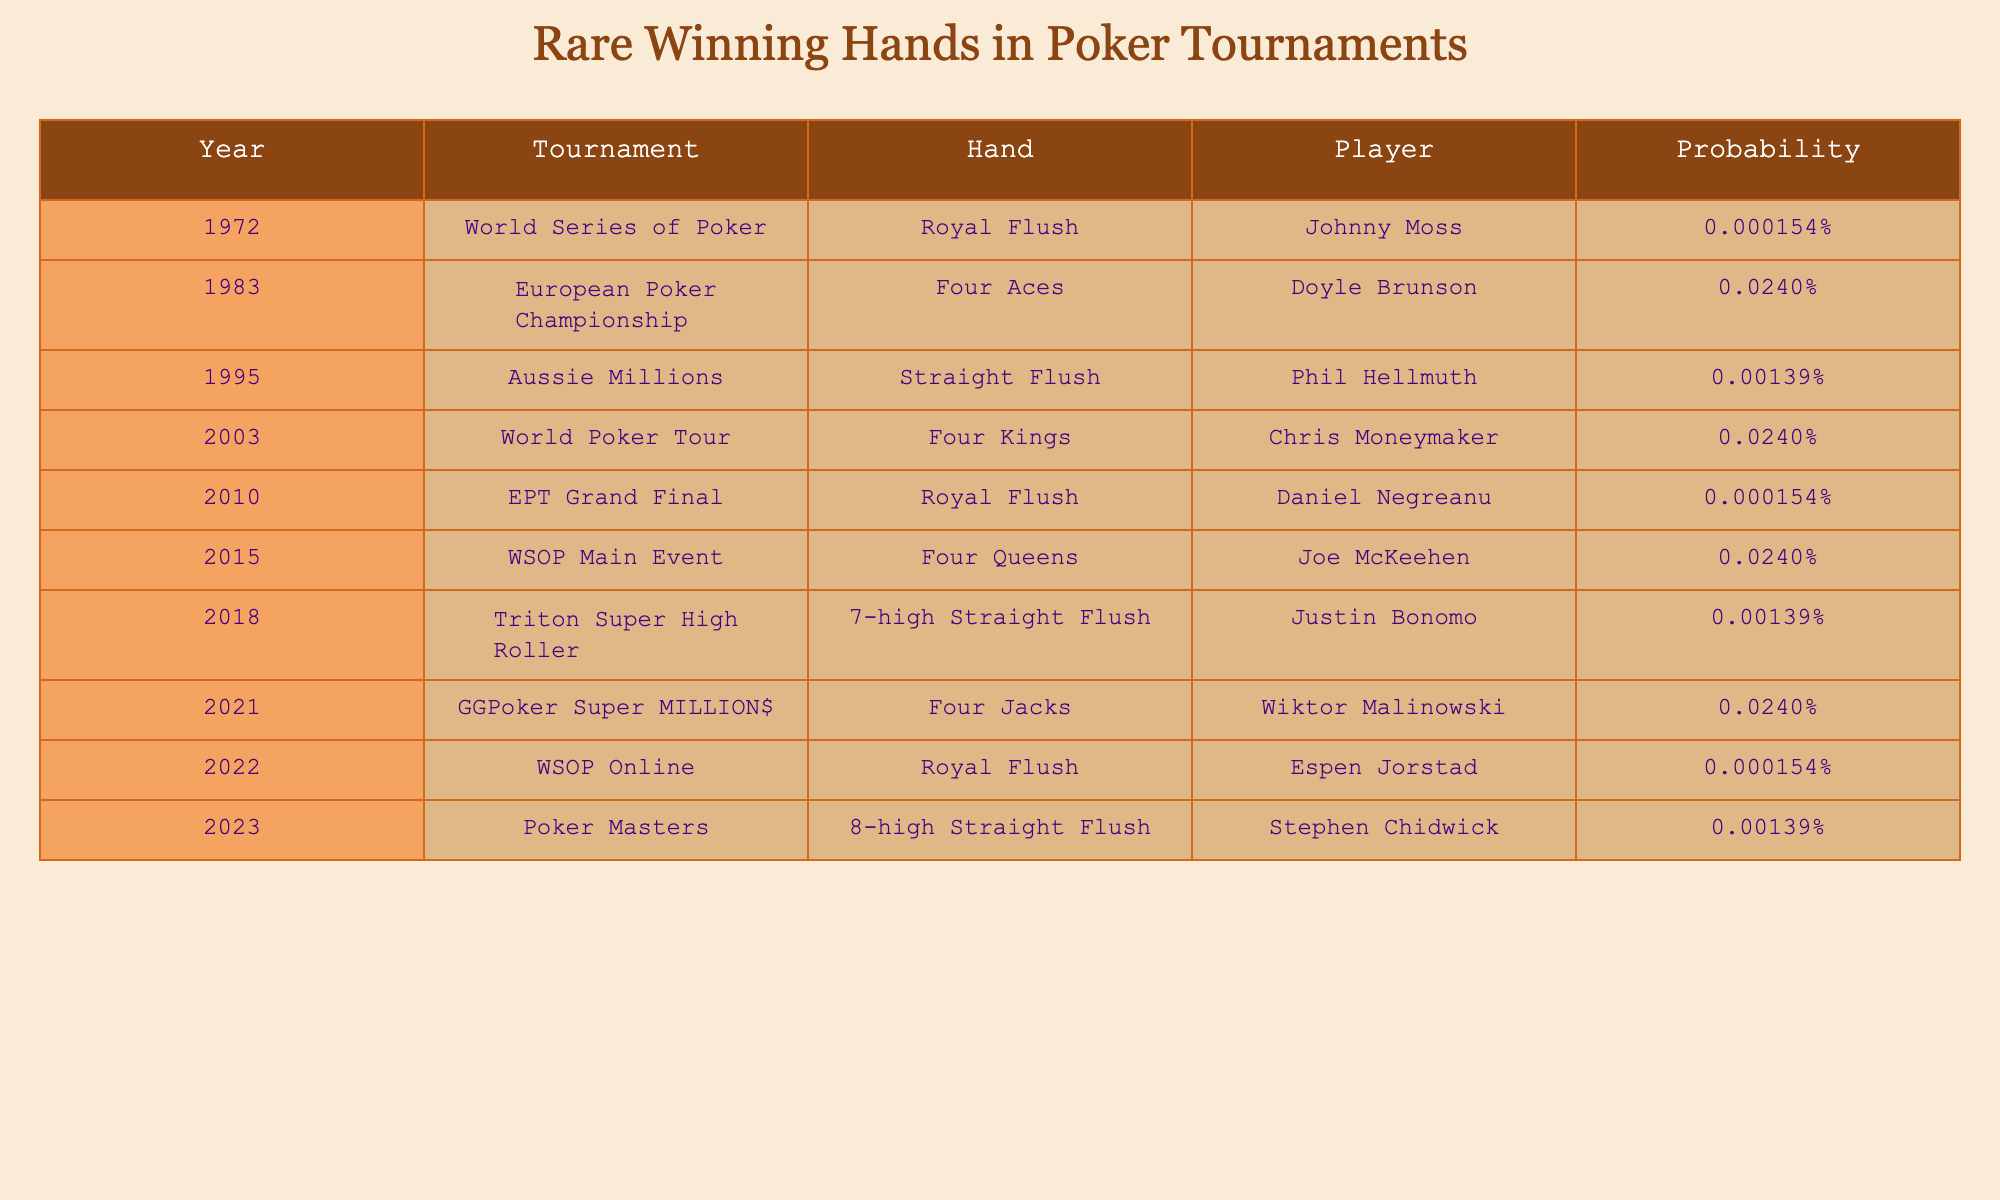What is the rarest winning hand recorded in the table? The table contains multiple winning hands with the same lowest probability of occurrence, specifically the Royal Flush, which appears three times (1972, 2010, and 2022). Each instance has a probability of 0.000154%. Therefore, the rarest winning hand is the Royal Flush.
Answer: Royal Flush Which player won with Four Aces, and in which year? According to the table, Doyle Brunson won with Four Aces in the year 1983. This is directly stated in the row corresponding to that hand.
Answer: Doyle Brunson, 1983 How many different types of winning hands were mentioned in the table? The table includes five distinct winning hands: Royal Flush, Four Aces, Straight Flush, Four Kings, and Four Queens. These can be counted from the different 'Hand' entries listed.
Answer: 5 Is it true that any player has won with a Royal Flush in more than one tournament? Based on the table, the Royal Flush has been recorded three times but always by different players in different years, suggesting no player has multiple wins with that hand. Thus, the answer is false.
Answer: False What is the average probability of winning hands recorded in the table? First, add the probabilities: 0.000154 + 0.0240 + 0.00139 + 0.0240 + 0.000154 + 0.0240 + 0.00139 + 0.0240 + 0.000154 + 0.00139. This gives a total of approximately 0.0775%. Then divide by the number of entries (10), which yields an average probability of around 0.00775%.
Answer: 0.00775% Which hand has the highest probability of occurrence, and what is that probability? By reviewing the table, the Four Aces, Four Kings, Four Queens, and Four Jacks all share the highest probability of 0.0240%. This is the highest value present in the table for winning hands.
Answer: Four Aces, 0.0240% How many years did it take for a player to win with a Royal Flush after the first occurrence in 1972? The next occurrence of a player winning with a Royal Flush after Johnny Moss in 1972 was in 2010, making the time span 2010 - 1972 = 38 years.
Answer: 38 years In what years did players achieve a probability of winning hands less than 0.002%? Reviewing the probabilities, the instances with less than 0.002% are 0.000154% and 0.00139%, which correspond to the years 1972 (Royal Flush), 2010 (Royal Flush), 2022 (Royal Flush), and 1995 (Straight Flush), 2018 (7-high Straight Flush), and 2023 (8-high Straight Flush). Thus, the years are 1972, 2010, 2022, 1995, 2018, 2023.
Answer: 1972, 2010, 2022, 1995, 2018, 2023 How many unique tournaments are represented in the table? The table lists tournaments: World Series of Poker, European Poker Championship, Aussie Millions, World Poker Tour, EPT Grand Final, WSOP Main Event, Triton Super High Roller, GGPoker Super MILLION$, WSOP Online, and Poker Masters. Counting these tournaments reveals ten unique tournaments.
Answer: 10 